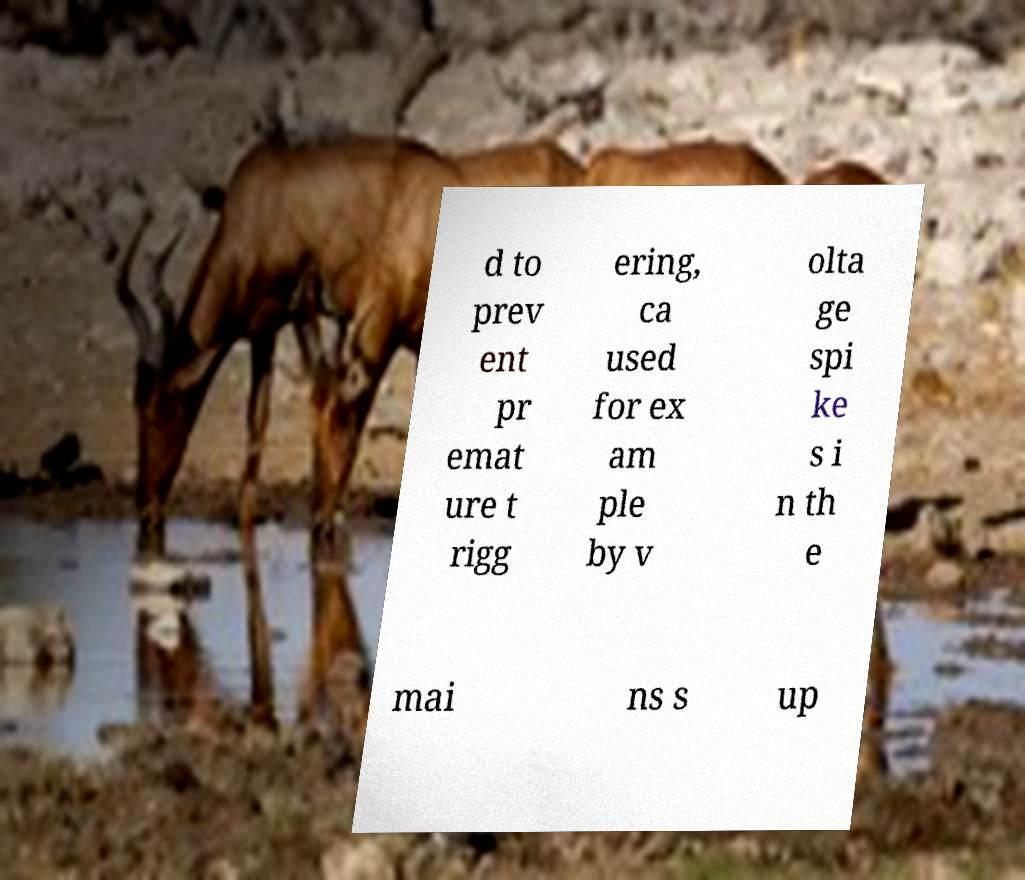Can you accurately transcribe the text from the provided image for me? d to prev ent pr emat ure t rigg ering, ca used for ex am ple by v olta ge spi ke s i n th e mai ns s up 